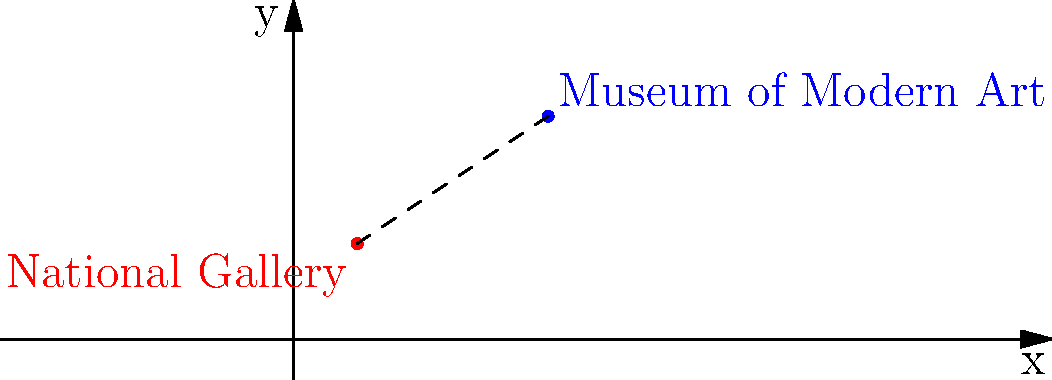On a city map coordinate system, the National Gallery is located at (2,3) and the Museum of Modern Art is at (8,7). Calculate the distance between these two famous art museums to the nearest tenth of a unit. To find the distance between two points on a coordinate plane, we can use the distance formula:

$$d = \sqrt{(x_2 - x_1)^2 + (y_2 - y_1)^2}$$

Where $(x_1, y_1)$ is the location of the National Gallery and $(x_2, y_2)$ is the location of the Museum of Modern Art.

Let's plug in the values:
$(x_1, y_1) = (2, 3)$
$(x_2, y_2) = (8, 7)$

Now, let's calculate:

1) $x_2 - x_1 = 8 - 2 = 6$
2) $y_2 - y_1 = 7 - 3 = 4$

Plugging these into the formula:

$$d = \sqrt{(6)^2 + (4)^2}$$

3) Simplify inside the parentheses:
   $$d = \sqrt{36 + 16}$$

4) Add under the square root:
   $$d = \sqrt{52}$$

5) Simplify the square root:
   $$d = 2\sqrt{13} \approx 7.2111$$

6) Rounding to the nearest tenth:
   $$d \approx 7.2$$

Therefore, the distance between the National Gallery and the Museum of Modern Art is approximately 7.2 units.
Answer: 7.2 units 